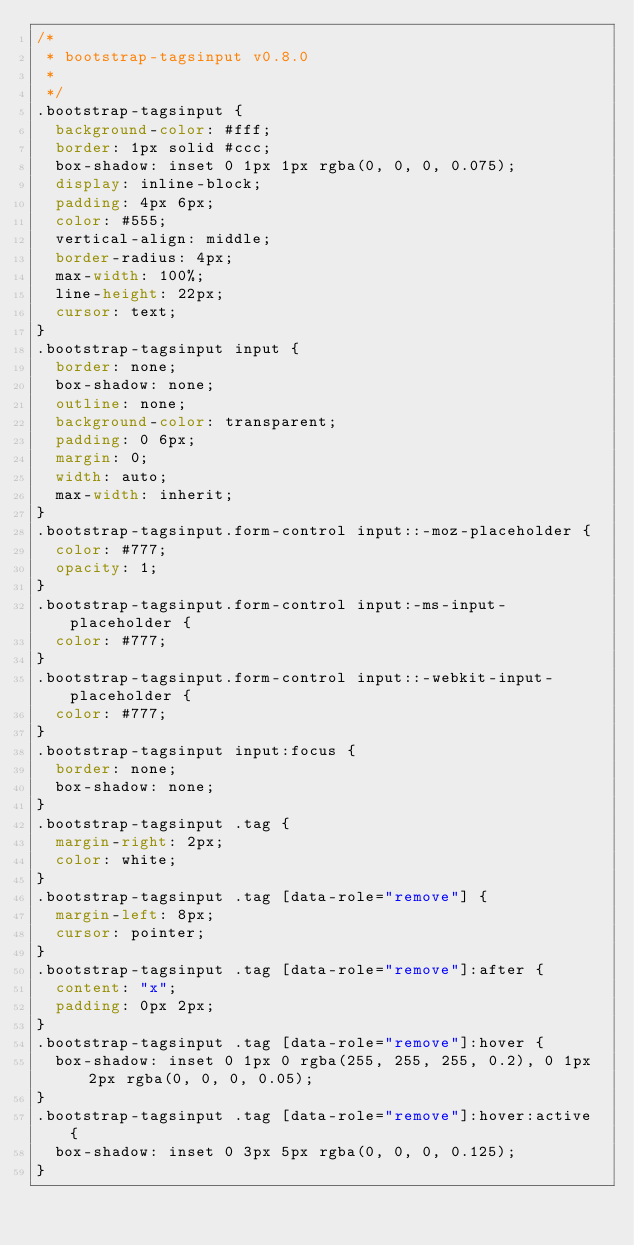<code> <loc_0><loc_0><loc_500><loc_500><_CSS_>/*
 * bootstrap-tagsinput v0.8.0
 * 
 */
.bootstrap-tagsinput {
  background-color: #fff;
  border: 1px solid #ccc;
  box-shadow: inset 0 1px 1px rgba(0, 0, 0, 0.075);
  display: inline-block;
  padding: 4px 6px;
  color: #555;
  vertical-align: middle;
  border-radius: 4px;
  max-width: 100%;
  line-height: 22px;
  cursor: text;
}
.bootstrap-tagsinput input {
  border: none;
  box-shadow: none;
  outline: none;
  background-color: transparent;
  padding: 0 6px;
  margin: 0;
  width: auto;
  max-width: inherit;
}
.bootstrap-tagsinput.form-control input::-moz-placeholder {
  color: #777;
  opacity: 1;
}
.bootstrap-tagsinput.form-control input:-ms-input-placeholder {
  color: #777;
}
.bootstrap-tagsinput.form-control input::-webkit-input-placeholder {
  color: #777;
}
.bootstrap-tagsinput input:focus {
  border: none;
  box-shadow: none;
}
.bootstrap-tagsinput .tag {
  margin-right: 2px;
  color: white;
}
.bootstrap-tagsinput .tag [data-role="remove"] {
  margin-left: 8px;
  cursor: pointer;
}
.bootstrap-tagsinput .tag [data-role="remove"]:after {
  content: "x";
  padding: 0px 2px;
}
.bootstrap-tagsinput .tag [data-role="remove"]:hover {
  box-shadow: inset 0 1px 0 rgba(255, 255, 255, 0.2), 0 1px 2px rgba(0, 0, 0, 0.05);
}
.bootstrap-tagsinput .tag [data-role="remove"]:hover:active {
  box-shadow: inset 0 3px 5px rgba(0, 0, 0, 0.125);
}
</code> 